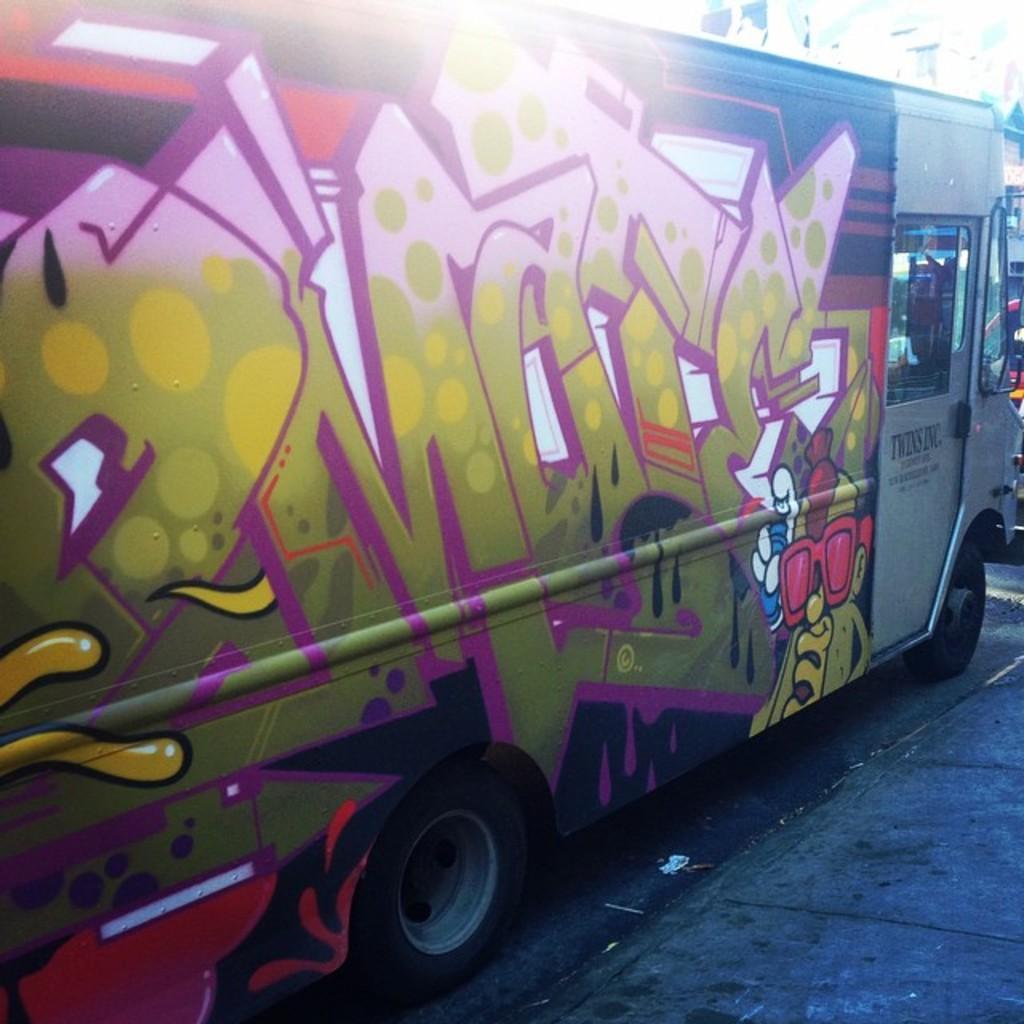How would you summarize this image in a sentence or two? There is a vehicle on the road which has a design on it. 